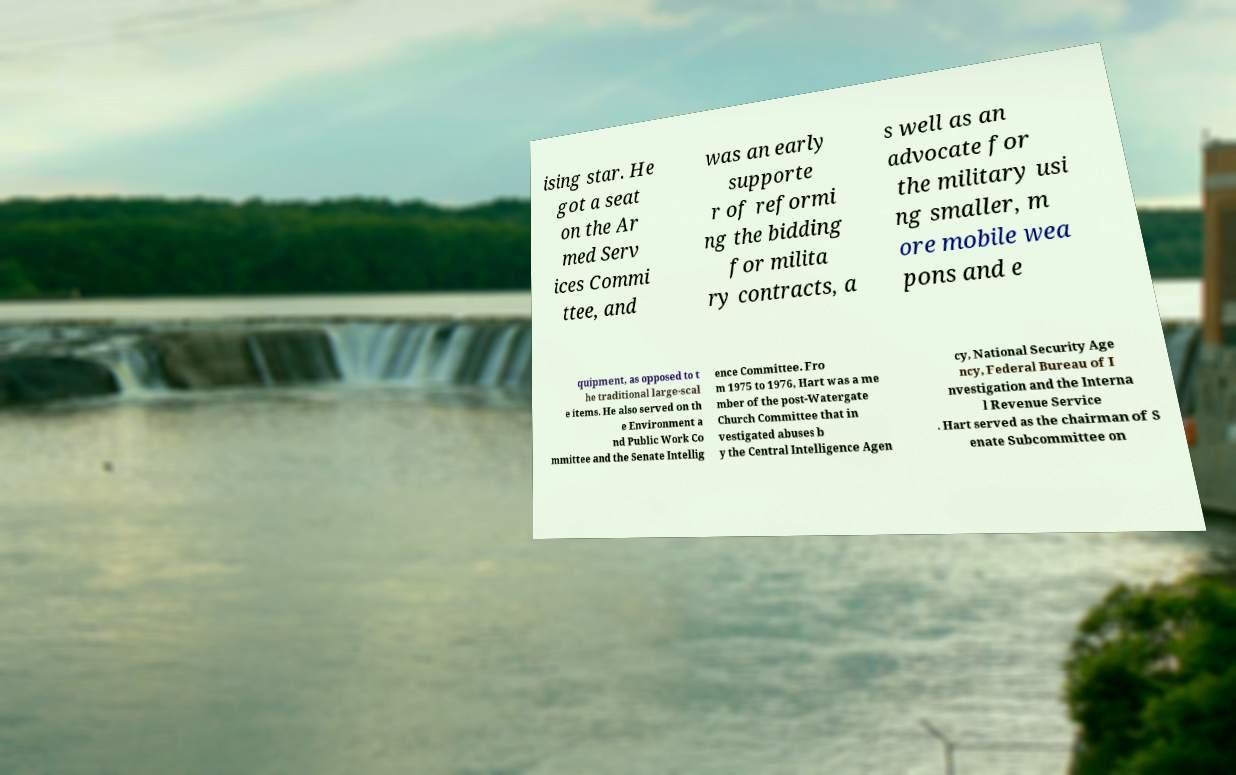Can you read and provide the text displayed in the image?This photo seems to have some interesting text. Can you extract and type it out for me? ising star. He got a seat on the Ar med Serv ices Commi ttee, and was an early supporte r of reformi ng the bidding for milita ry contracts, a s well as an advocate for the military usi ng smaller, m ore mobile wea pons and e quipment, as opposed to t he traditional large-scal e items. He also served on th e Environment a nd Public Work Co mmittee and the Senate Intellig ence Committee. Fro m 1975 to 1976, Hart was a me mber of the post-Watergate Church Committee that in vestigated abuses b y the Central Intelligence Agen cy, National Security Age ncy, Federal Bureau of I nvestigation and the Interna l Revenue Service . Hart served as the chairman of S enate Subcommittee on 